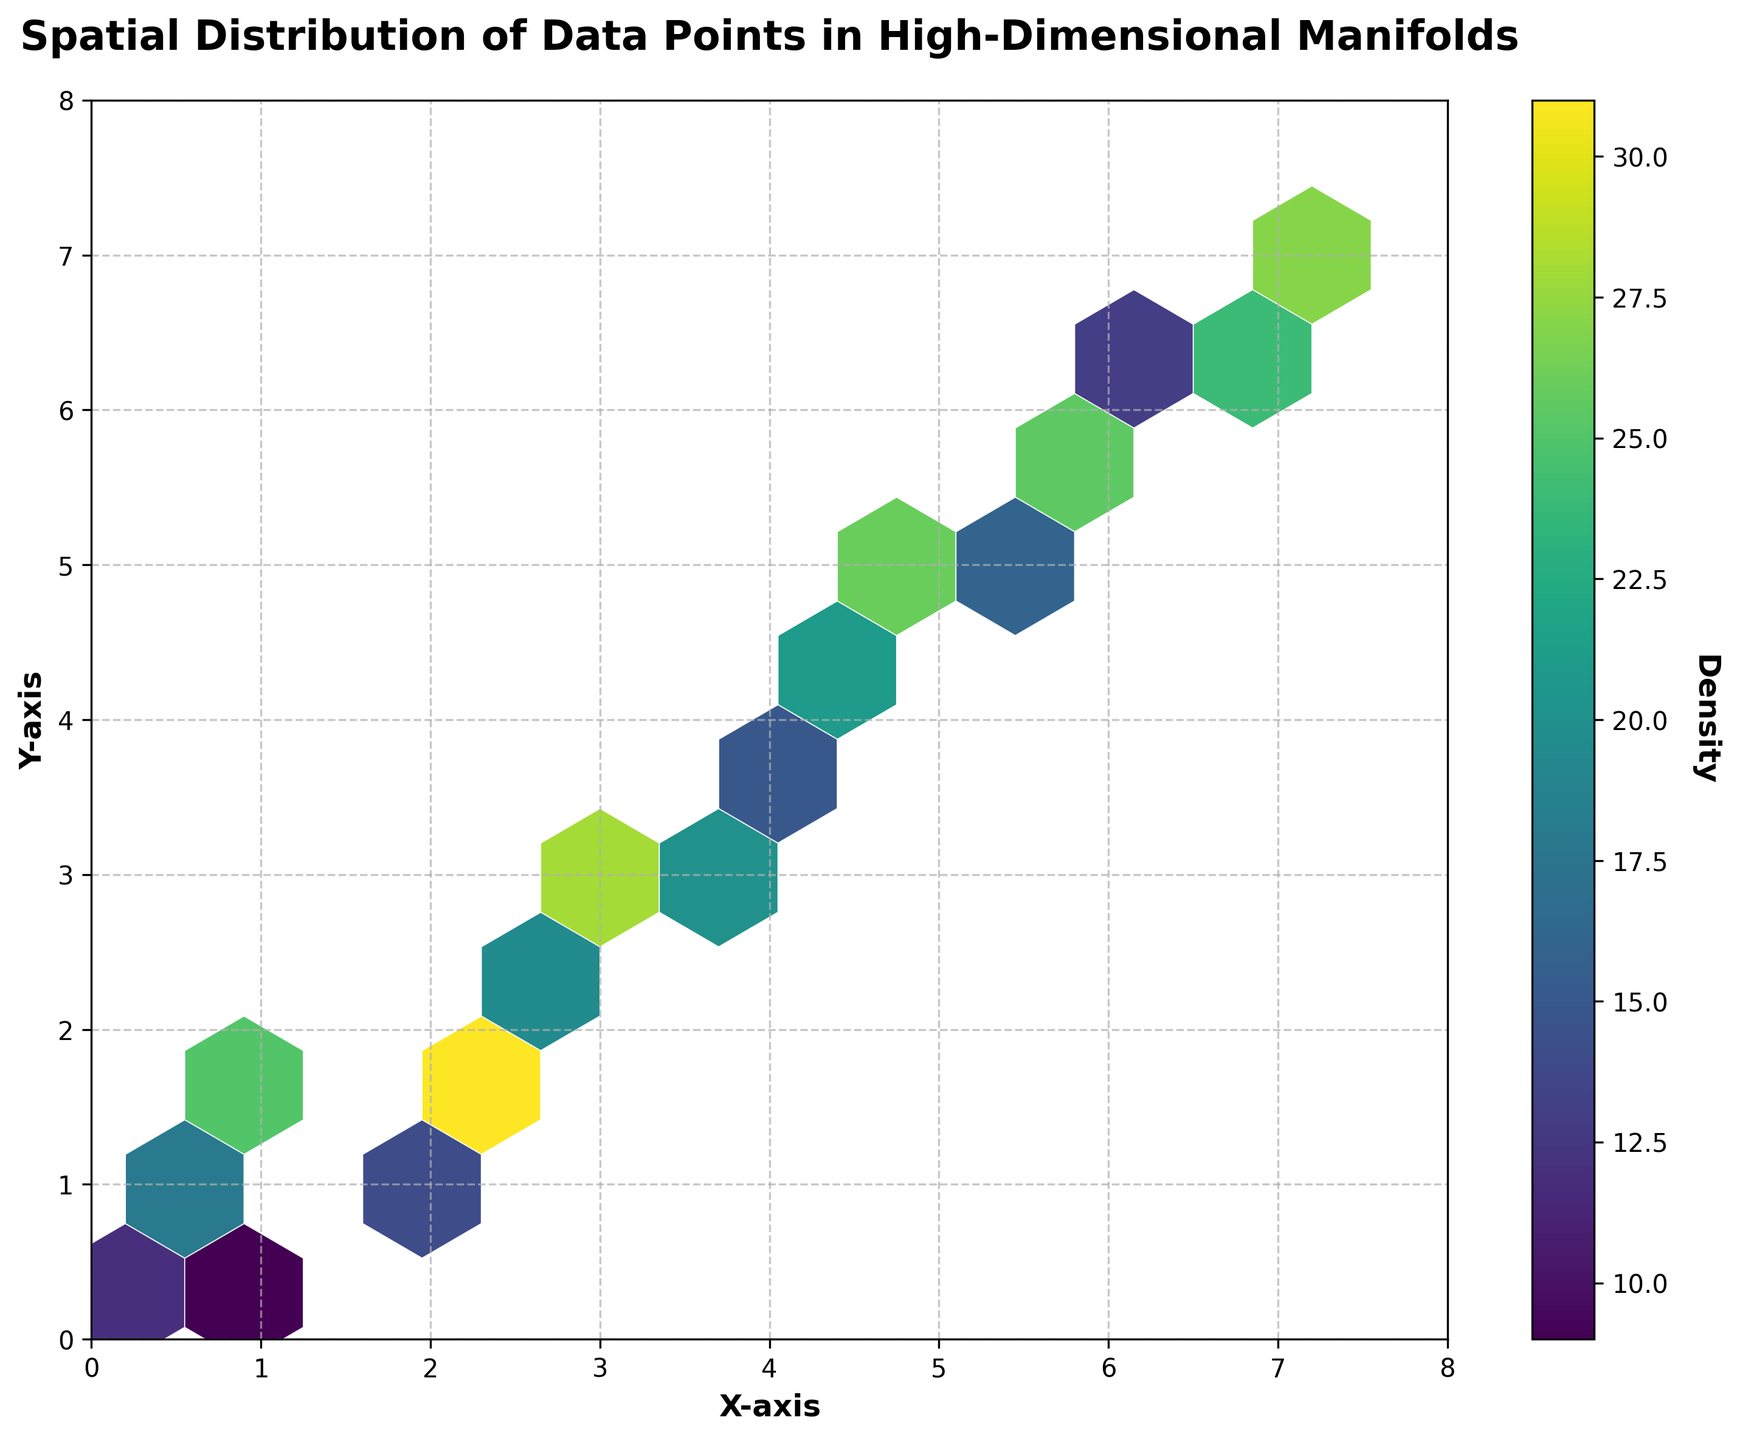What is the title of the figure? The title of the figure can be found at the top of the plot, typically written in larger, bold font. In this case, it is clearly mentioned at the top as 'Spatial Distribution of Data Points in High-Dimensional Manifolds'.
Answer: Spatial Distribution of Data Points in High-Dimensional Manifolds What do the color variations in the hexagons represent? The color variations in the hexagons represent the density of data points, where different colors indicate varying levels of density. The color bar on the right provides a reference for these density values.
Answer: Density of data points Which color on the plot indicates the highest density? By looking at the color bar attached to the plot, the color representing the highest density can be identified as the one mapped to the highest value. In this plot, it is represented by the brightest color.
Answer: Brightest color What are the labels of the X and Y axes? The labels of the X and Y axes are found directly beside each respective axis. For this plot, they are labeled 'X-axis' and 'Y-axis'.
Answer: X-axis and Y-axis What is the density value at the point (2.1, 1.8)? To determine the density value at (2.1, 1.8), locate this hexagon on the plot, and match its color to the color bar.
Answer: 31 Which region of the plot has the highest density values? By examining the plot, identify the regions with the brightest colors, as these indicate the highest density values. The hexagons around (2.1, 1.8) appear to have the brightest color.
Answer: Around (2.1, 1.8) What are the minimum and maximum density values based on the color bar? Referring to the color bar on the plot, the minimum density value starts from a darker shade and maxes out at the brightest shade.
Answer: Minimum: 9, Maximum: 31 How does the density distribution change as you move from bottom left to top right of the plot? Observe the color gradients from the bottom left to the top right of the plot. The colors generally transition from lower densities (darker shades) to higher densities (brighter shades).
Answer: Increases from low to high density Compare the density at (0.5, 0.7) and (5.0, 4.8). Which one is greater? By locating the two hexagons on the plot and comparing their colors using the color bar, we determine their relative densities.
Answer: (5.0, 4.8) What is the density difference between the points (1.2, 1.5) and (4.2, 4.1)? First, find the density values for each point using the color bar. The density at (1.2, 1.5) is 25 and at (4.2, 4.1) is 23. Then calculate the difference (25 - 23).
Answer: 2 